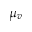<formula> <loc_0><loc_0><loc_500><loc_500>\mu _ { v }</formula> 